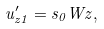<formula> <loc_0><loc_0><loc_500><loc_500>u _ { z 1 } ^ { \prime } = s _ { 0 } W z ,</formula> 